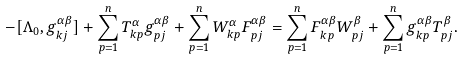Convert formula to latex. <formula><loc_0><loc_0><loc_500><loc_500>- [ \Lambda _ { 0 } , g _ { k j } ^ { \alpha \beta } ] + \sum _ { p = 1 } ^ { n } T _ { k p } ^ { \alpha } g _ { p j } ^ { \alpha \beta } + \sum _ { p = 1 } ^ { n } W _ { k p } ^ { \alpha } F _ { p j } ^ { \alpha \beta } = \sum _ { p = 1 } ^ { n } F _ { k p } ^ { \alpha \beta } W _ { p j } ^ { \beta } + \sum _ { p = 1 } ^ { n } g _ { k p } ^ { \alpha \beta } T _ { p j } ^ { \beta } .</formula> 